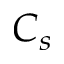<formula> <loc_0><loc_0><loc_500><loc_500>C _ { s }</formula> 